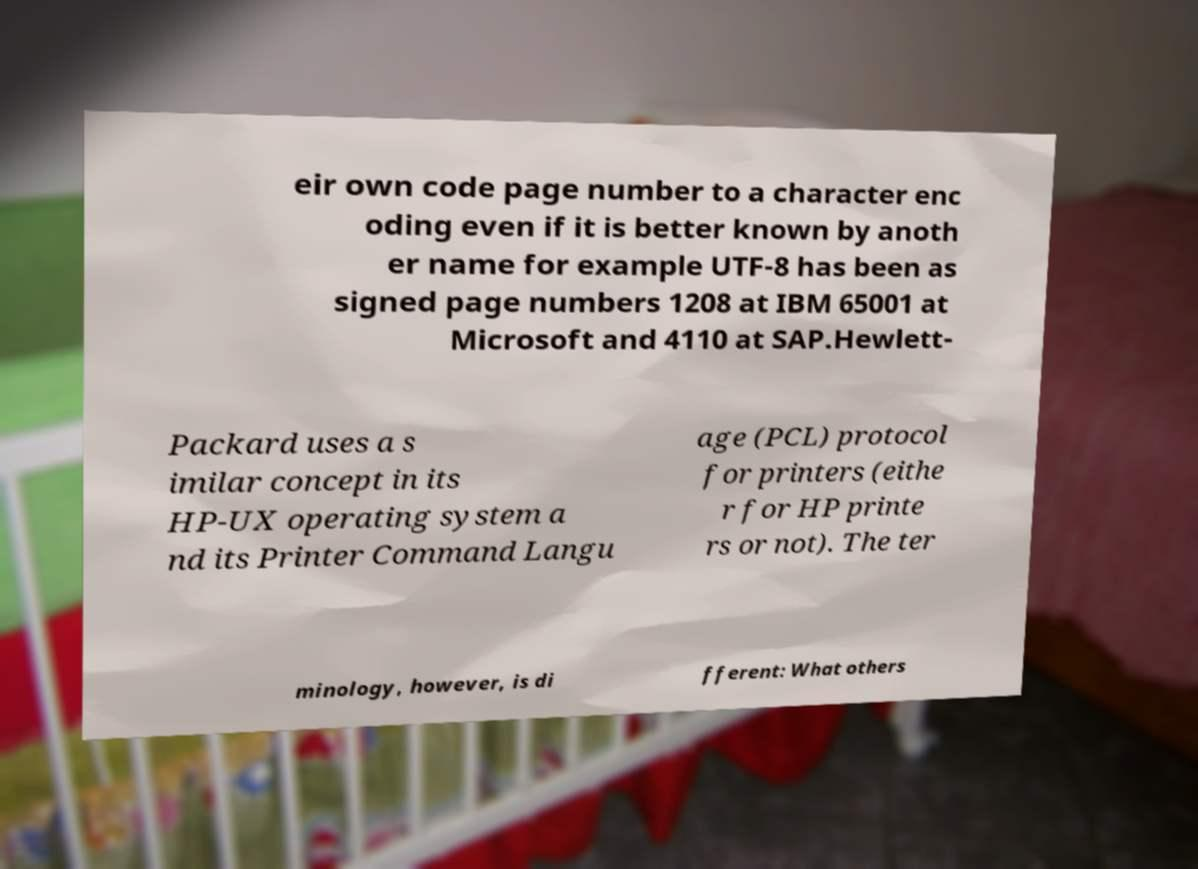What messages or text are displayed in this image? I need them in a readable, typed format. eir own code page number to a character enc oding even if it is better known by anoth er name for example UTF-8 has been as signed page numbers 1208 at IBM 65001 at Microsoft and 4110 at SAP.Hewlett- Packard uses a s imilar concept in its HP-UX operating system a nd its Printer Command Langu age (PCL) protocol for printers (eithe r for HP printe rs or not). The ter minology, however, is di fferent: What others 